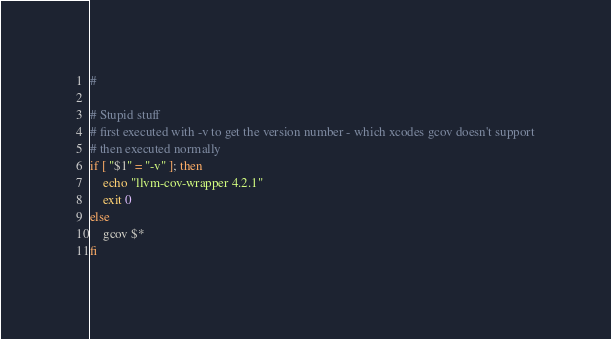<code> <loc_0><loc_0><loc_500><loc_500><_Bash_>#

# Stupid stuff
# first executed with -v to get the version number - which xcodes gcov doesn't support
# then executed normally
if [ "$1" = "-v" ]; then
    echo "llvm-cov-wrapper 4.2.1"
    exit 0
else
    gcov $*
fi

</code> 